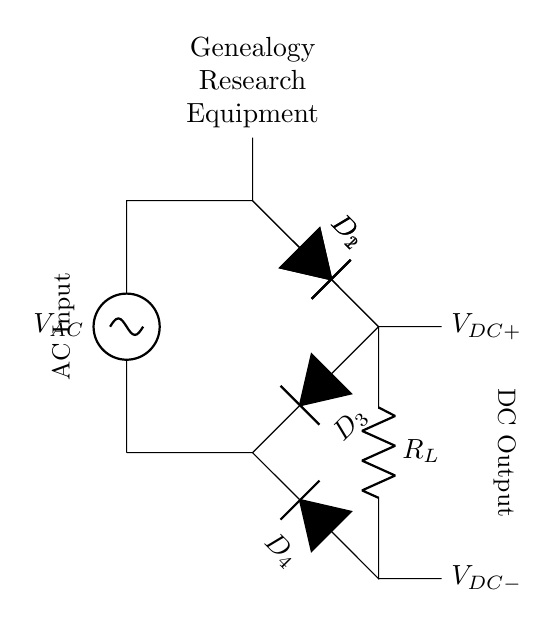What is the input voltage type? The input voltage type is AC, indicated by the label attached to the voltage source in the diagram. AC stands for alternating current, and it is commonly used for powering various electrical devices.
Answer: AC How many diodes are in the bridge rectifier? There are four diodes in the bridge rectifier, as represented by D1, D2, D3, and D4 in the circuit diagram. Each diode plays a role in directing the current during positive and negative halves of the AC input.
Answer: 4 What does R_L represent in the circuit? R_L represents the load resistor in the circuit, symbolizing the part of the circuit where the DC output is utilized. It is essential for regulating the current drawn from the rectifier.
Answer: Load resistor What type of output does this rectifier provide? The rectifier provides DC output, indicated by the labels V_DC+ and V_DC- which denote the positive and negative terminals of the direct current produced by the circuit.
Answer: DC Which components allow current to flow in one direction? The diodes (D1, D2, D3, and D4) allow current to flow in one direction, as they are designed to conduct current only when they are forward-biased. This characteristic is fundamental for converting AC voltage to DC voltage in the rectifier.
Answer: Diodes What is the purpose of the diode bridge configuration? The purpose of the diode bridge configuration is to convert both halves of the AC signal into DC output, ensuring that the output remains unidirectional regardless of the input polarity. This maximizes the efficiency of the rectification process.
Answer: Rectification What role does the load resistor play in genealogy research equipment? The load resistor regulates the current flowing to the genealogy research equipment, which may be sensitive to voltage levels. It ensures that the connected equipment operates correctly without damage.
Answer: Current regulation 